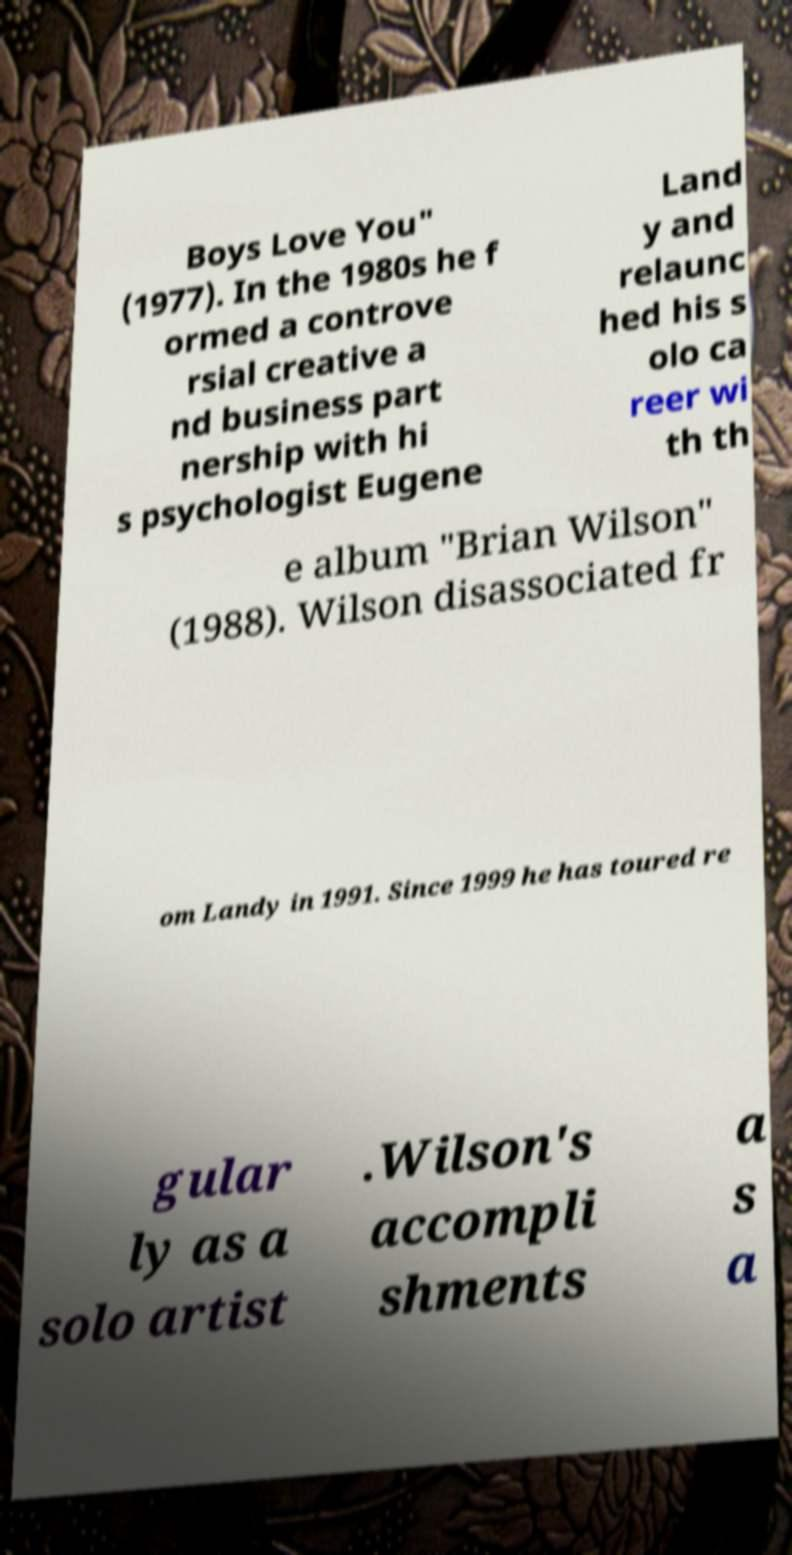Can you accurately transcribe the text from the provided image for me? Boys Love You" (1977). In the 1980s he f ormed a controve rsial creative a nd business part nership with hi s psychologist Eugene Land y and relaunc hed his s olo ca reer wi th th e album "Brian Wilson" (1988). Wilson disassociated fr om Landy in 1991. Since 1999 he has toured re gular ly as a solo artist .Wilson's accompli shments a s a 